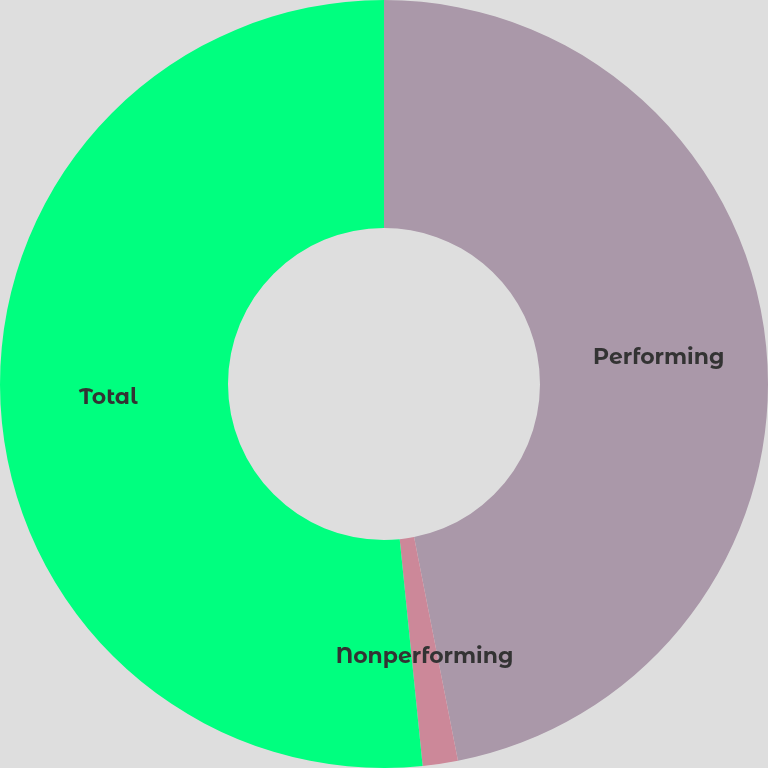Convert chart. <chart><loc_0><loc_0><loc_500><loc_500><pie_chart><fcel>Performing<fcel>Nonperforming<fcel>Total<nl><fcel>46.91%<fcel>1.48%<fcel>51.6%<nl></chart> 